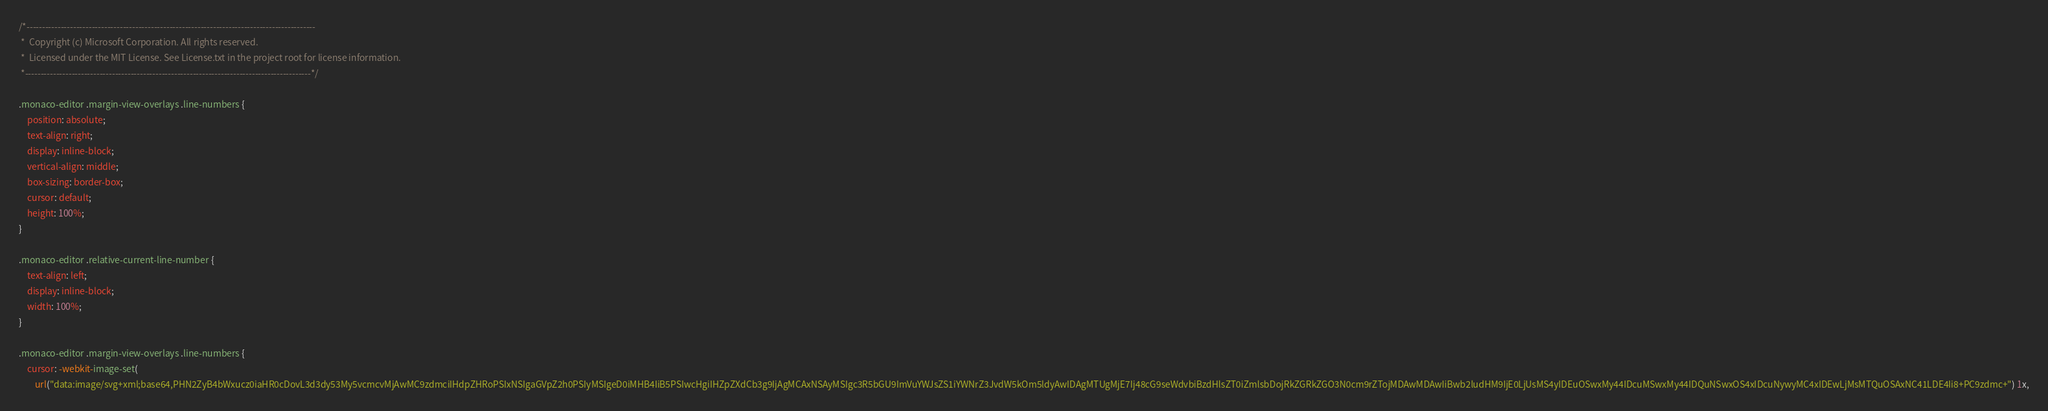Convert code to text. <code><loc_0><loc_0><loc_500><loc_500><_CSS_>/*---------------------------------------------------------------------------------------------
 *  Copyright (c) Microsoft Corporation. All rights reserved.
 *  Licensed under the MIT License. See License.txt in the project root for license information.
 *--------------------------------------------------------------------------------------------*/

.monaco-editor .margin-view-overlays .line-numbers {
	position: absolute;
	text-align: right;
	display: inline-block;
	vertical-align: middle;
	box-sizing: border-box;
	cursor: default;
	height: 100%;
}

.monaco-editor .relative-current-line-number {
	text-align: left;
	display: inline-block;
	width: 100%;
}

.monaco-editor .margin-view-overlays .line-numbers {
	cursor: -webkit-image-set(
		url("data:image/svg+xml;base64,PHN2ZyB4bWxucz0iaHR0cDovL3d3dy53My5vcmcvMjAwMC9zdmciIHdpZHRoPSIxNSIgaGVpZ2h0PSIyMSIgeD0iMHB4IiB5PSIwcHgiIHZpZXdCb3g9IjAgMCAxNSAyMSIgc3R5bGU9ImVuYWJsZS1iYWNrZ3JvdW5kOm5ldyAwIDAgMTUgMjE7Ij48cG9seWdvbiBzdHlsZT0iZmlsbDojRkZGRkZGO3N0cm9rZTojMDAwMDAwIiBwb2ludHM9IjE0LjUsMS4yIDEuOSwxMy44IDcuMSwxMy44IDQuNSwxOS4xIDcuNywyMC4xIDEwLjMsMTQuOSAxNC41LDE4Ii8+PC9zdmc+") 1x,</code> 